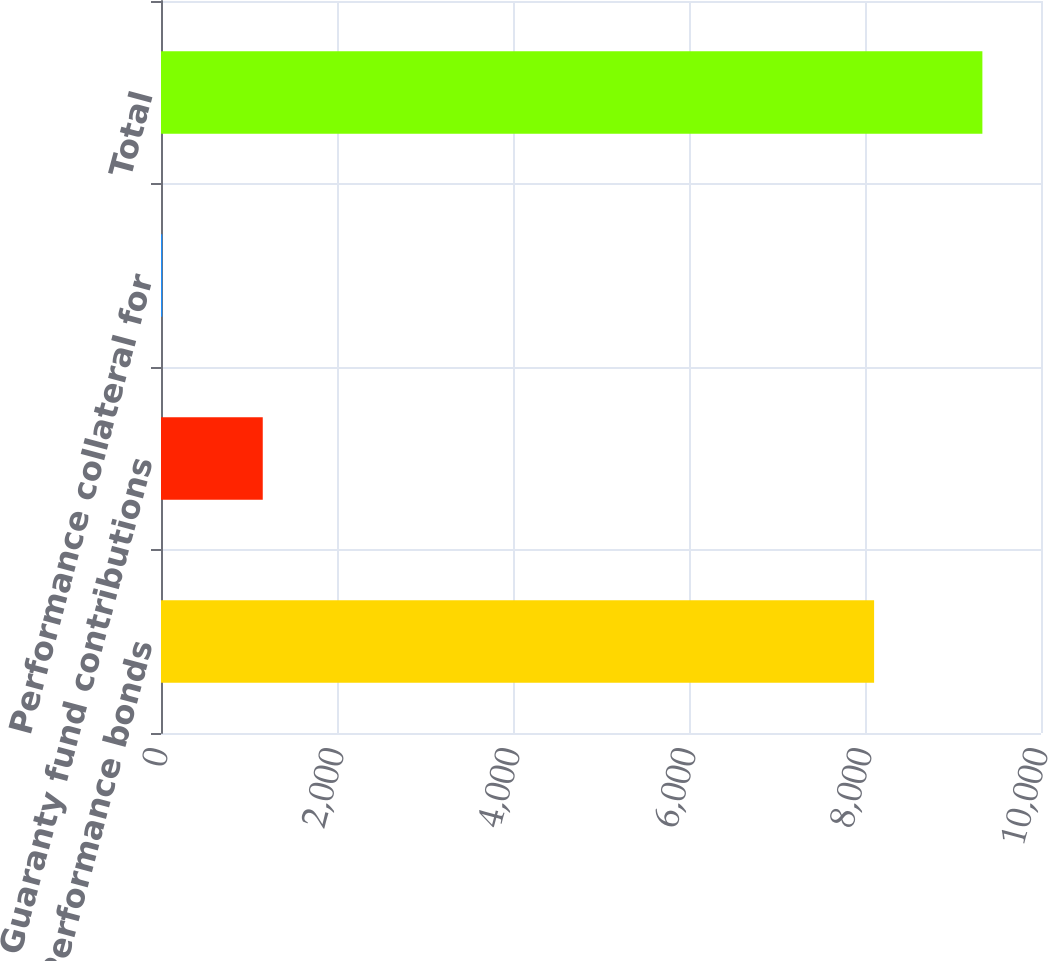Convert chart. <chart><loc_0><loc_0><loc_500><loc_500><bar_chart><fcel>Performance bonds<fcel>Guaranty fund contributions<fcel>Performance collateral for<fcel>Total<nl><fcel>8103.4<fcel>1156.3<fcel>14.2<fcel>9333.9<nl></chart> 